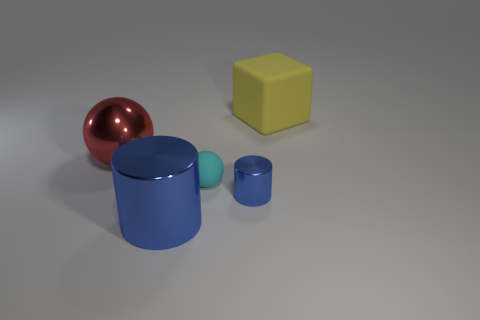What is the color of the object that is behind the large cylinder and in front of the cyan matte sphere?
Offer a terse response. Blue. Does the blue metallic cylinder that is left of the tiny cyan matte sphere have the same size as the thing that is behind the large red sphere?
Provide a succinct answer. Yes. What number of things are shiny things that are in front of the red metal object or big metallic cylinders?
Your response must be concise. 2. What is the tiny sphere made of?
Your answer should be compact. Rubber. Does the rubber block have the same size as the red sphere?
Provide a succinct answer. Yes. What number of cylinders are small gray matte objects or rubber objects?
Your answer should be compact. 0. The sphere that is to the right of the large metallic object behind the small cyan ball is what color?
Ensure brevity in your answer.  Cyan. Are there fewer large red balls that are in front of the small ball than shiny things to the right of the big matte object?
Offer a terse response. No. There is a cyan sphere; does it have the same size as the object behind the metallic sphere?
Provide a succinct answer. No. What shape is the thing that is both to the right of the cyan sphere and in front of the yellow matte cube?
Keep it short and to the point. Cylinder. 